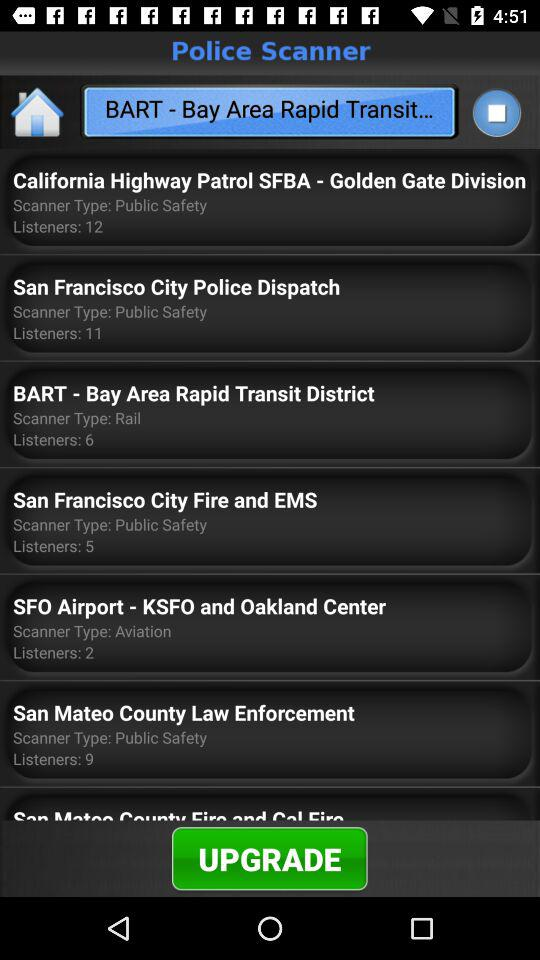How many listeners are in "SFO Airport - KSFO and Oakland Center"? There are 2 listeners in "SFO Airport - KSFO and Oakland Center". 